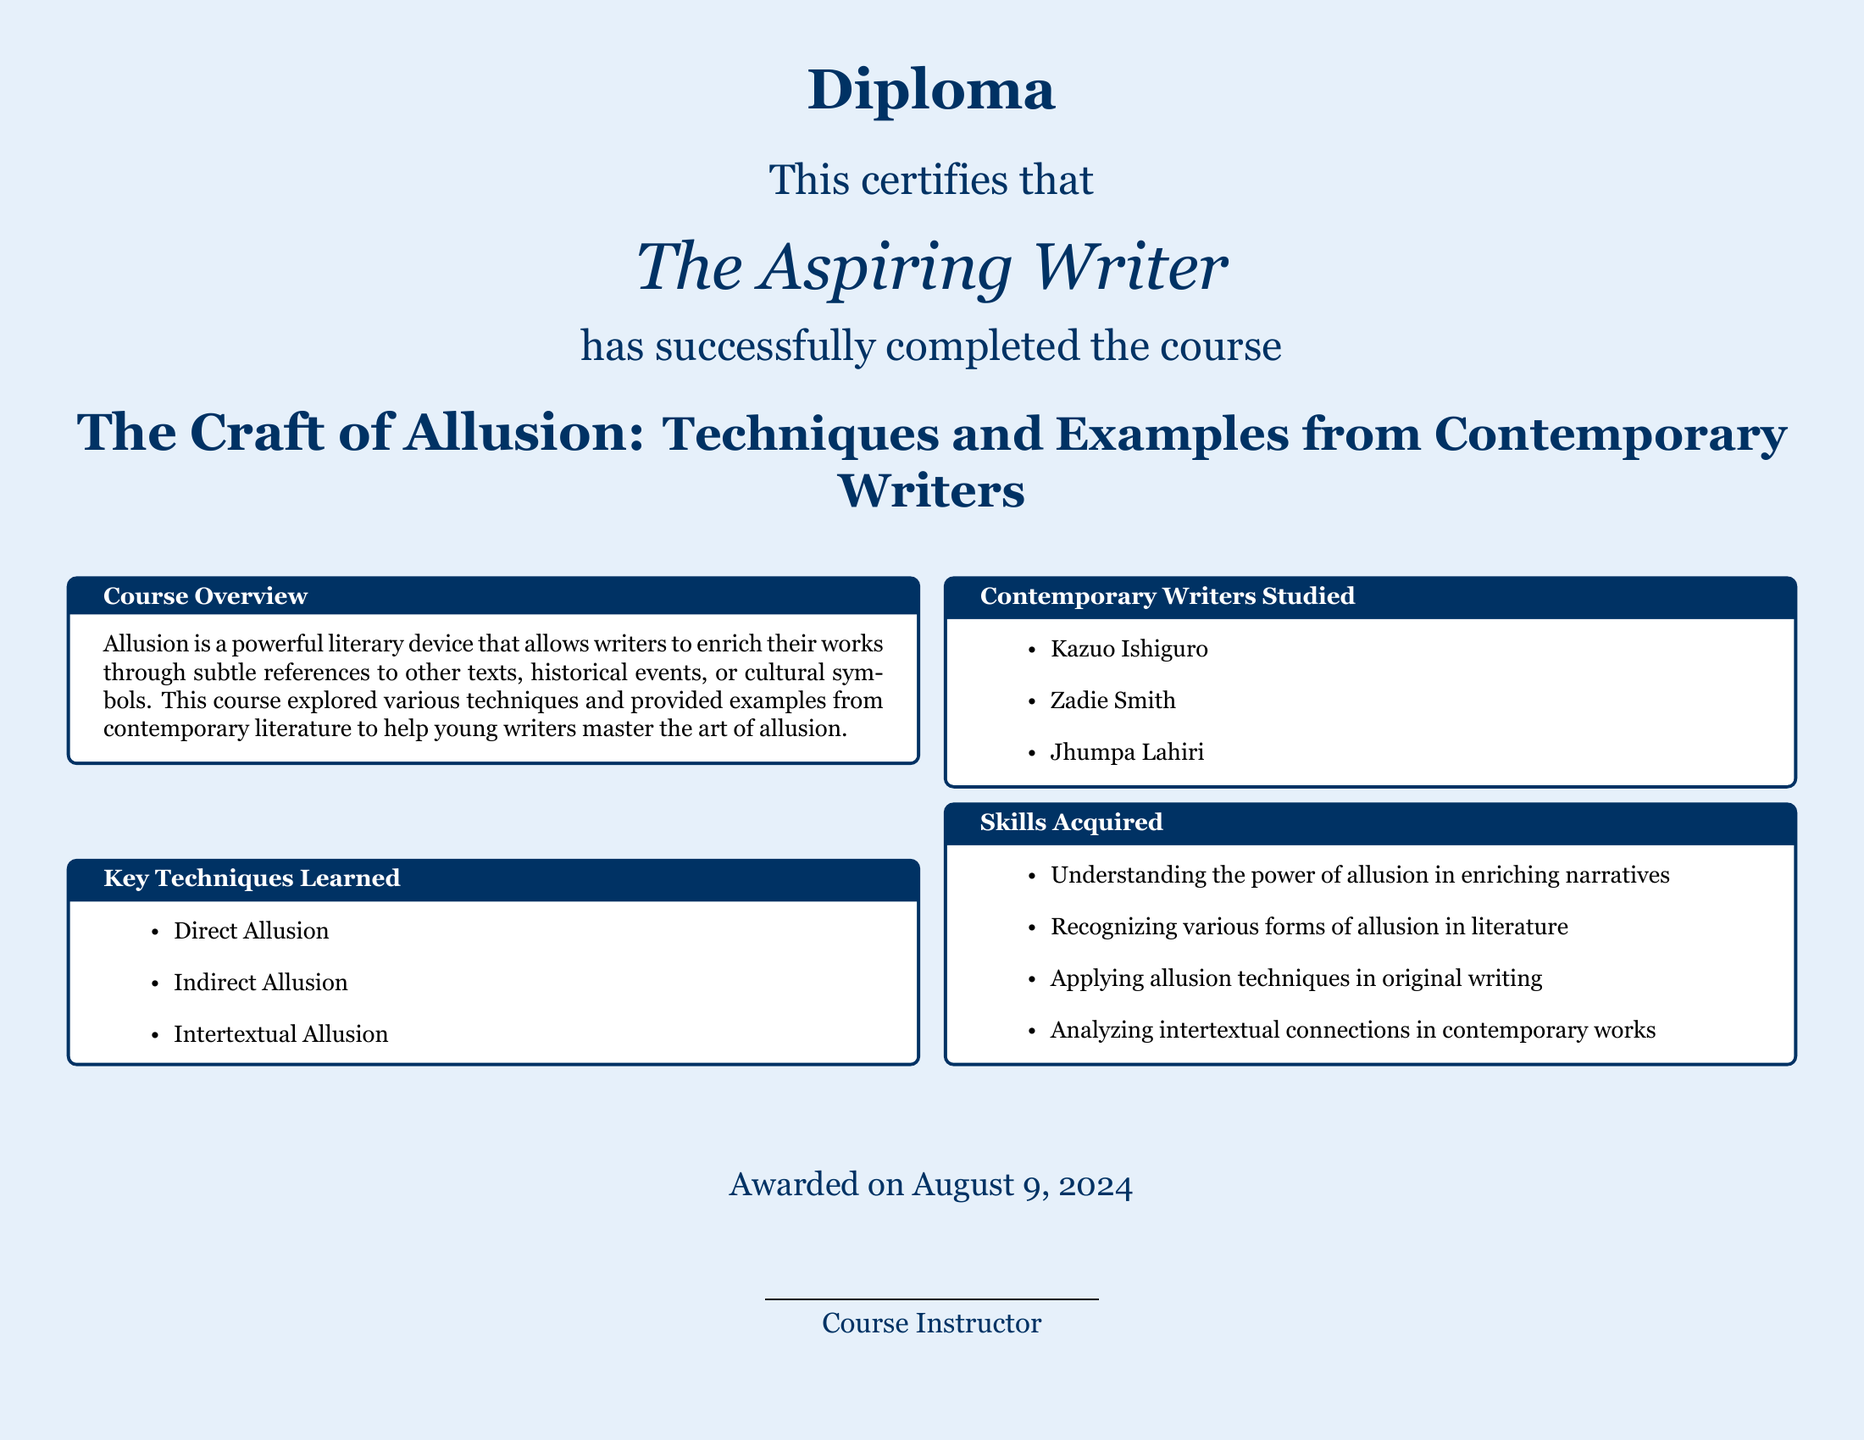What is the title of the course? The title of the course is explicitly stated in the document and is: The Craft of Allusion: Techniques and Examples from Contemporary Writers.
Answer: The Craft of Allusion: Techniques and Examples from Contemporary Writers Who is the awarded recipient of the diploma? The document certifies that The Aspiring Writer is the recipient of the diploma.
Answer: The Aspiring Writer What is the primary literary device discussed in the course? The course overview mentions that allusion is the powerful literary device discussed throughout the course.
Answer: Allusion Which contemporary writer is mentioned first in the studied list? The list of contemporary writers is provided in the document, where the first mentioned is Kazuo Ishiguro.
Answer: Kazuo Ishiguro What skill involves applying allusion techniques in writing? The document lists skills acquired in the course, including one that specifically mentions applying allusion techniques in original writing.
Answer: Applying allusion techniques in original writing How many key techniques were learned in the course? The document lists three key techniques learned in the course under the Key Techniques Learned section.
Answer: Three On what date was the diploma awarded? The document states that the diploma was awarded on the current date, which is noted as: today.
Answer: today What color is the background of the document? The document mentions a specific color for the page background, which is light blue.
Answer: light blue 